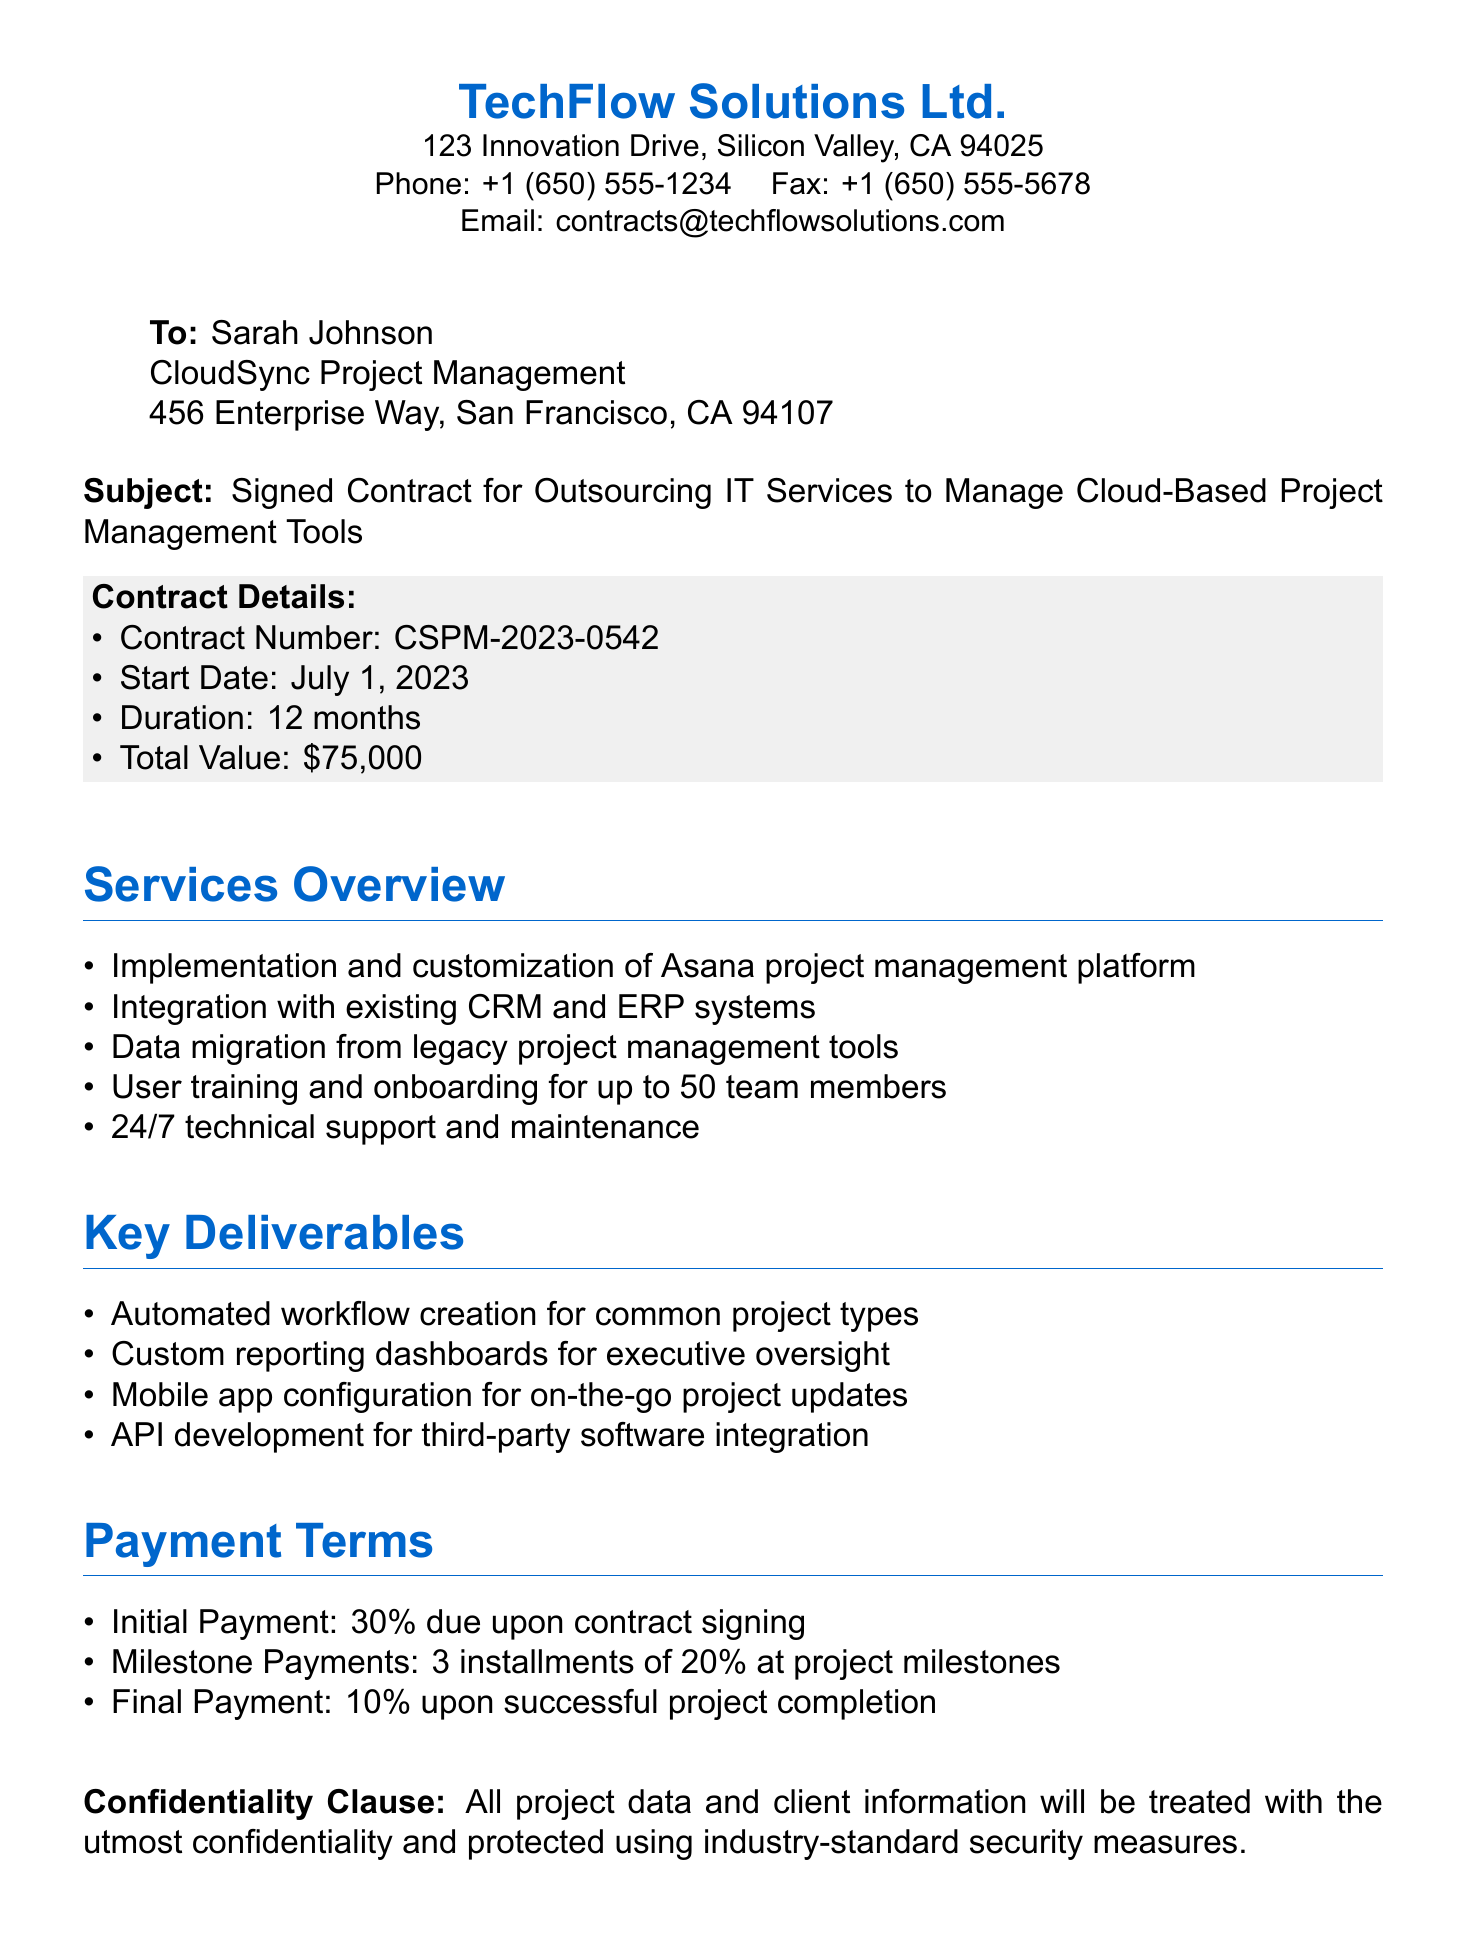What is the contract number? The contract number is specified in the document, which is CSPM-2023-0542.
Answer: CSPM-2023-0542 When does the contract start? The start date of the contract is mentioned in the document as July 1, 2023.
Answer: July 1, 2023 What is the total value of the contract? The total value is given in the contract details as $75,000.
Answer: $75,000 How long is the duration of the contract? The duration of the contract is noted in the document as 12 months.
Answer: 12 months What percentage is the initial payment? The percentage of the initial payment due upon contract signing is specified as 30%.
Answer: 30% What type of platform will be implemented? The platform specified for implementation in the document is the Asana project management platform.
Answer: Asana How many team members will receive user training? The document states that user training is provided for up to 50 team members.
Answer: 50 team members Who signed the contract? The document indicates that John Smith, CEO of TechFlow Solutions Ltd., signed the contract.
Answer: John Smith What kind of support is included in the services? The support included in the services is specified as 24/7 technical support and maintenance.
Answer: 24/7 technical support and maintenance What is the payment structure for milestone payments? The document states that milestone payments consist of 3 installments of 20% at project milestones.
Answer: 3 installments of 20% 